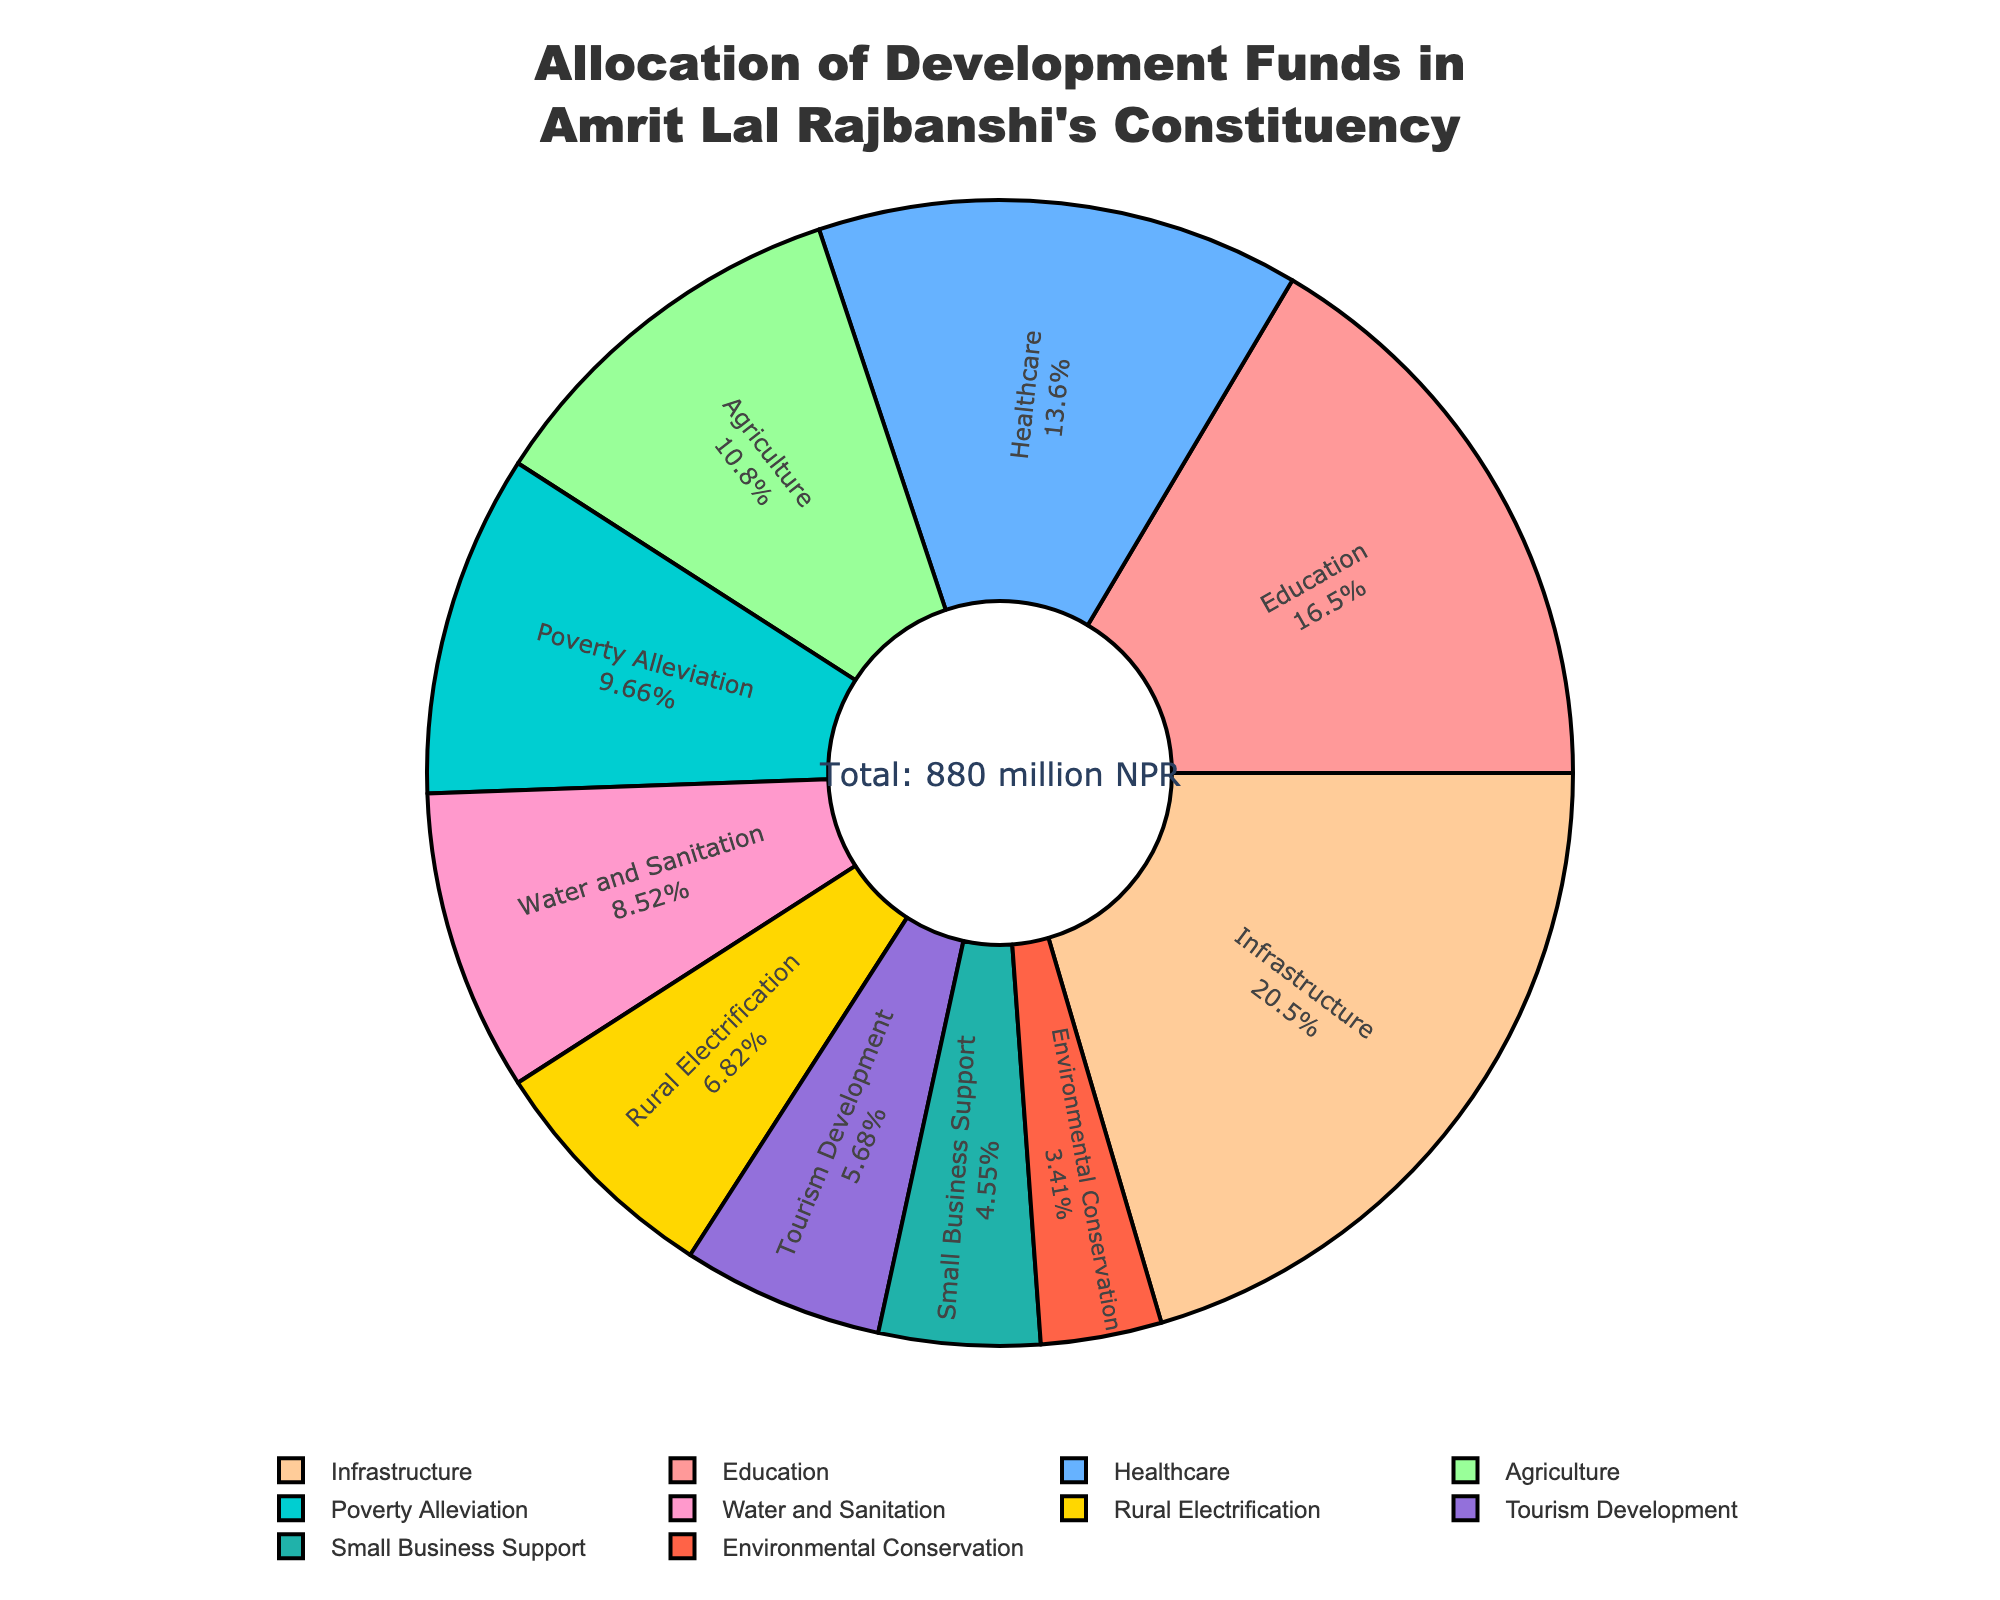What sector has the highest allocation of development funds? By looking at the size and the label of the largest section in the pie chart, we see that Infrastructure has the biggest allocation.
Answer: Infrastructure What percentage of the total development funds is allocated to Education? The pie chart provides labels with both sector names and their corresponding percentages. The percentage of funds allocated to Education can be read directly from the chart.
Answer: 20% How much more funds are allocated to Infrastructure compared to Environmental Conservation? Identify the allocations for both sectors from the pie chart: Infrastructure has 180 million NPR, and Environmental Conservation has 30 million NPR. Subtract the allocation of Environmental Conservation from Infrastructure: 180 - 30.
Answer: 150 million NPR Which sector has a smaller allocation of funds than Agriculture but a higher allocation than Environmental Conservation? Identify the allocations for Agriculture (95 million NPR) and Environmental Conservation (30 million NPR) from the pie chart, then look for a sector whose allocation is between these two values.
Answer: Poverty Alleviation What is the sum of allocations for sectors related to sustainability (Water and Sanitation, Rural Electrification, and Environmental Conservation)? Identify the allocations for these sectors: Water and Sanitation (75 million NPR), Rural Electrification (60 million NPR), and Environmental Conservation (30 million NPR). Sum these values: 75 + 60 + 30.
Answer: 165 million NPR How does the allocation for Healthcare compare to that for Small Business Support? The chart shows the allocation for Healthcare as 120 million NPR and for Small Business Support as 40 million NPR. Compare these two values by calculating the ratio: 120 / 40.
Answer: 3 times more Which two sectors, when their funds are combined, come closest to the total allocation for Infrastructure? The allocation for Infrastructure is 180 million NPR. Identify sector allocations that, when combined, are close to 180 million NPR. Education (145 million NPR) and Small Business Support (40 million NPR) combined make 145 + 40 = 185 million NPR.
Answer: Education and Small Business Support What is the difference in allocation between Agriculture and Tourism Development? The pie chart shows Agriculture with 95 million NPR and Tourism Development with 50 million NPR. Subtract the latter from the former: 95 - 50.
Answer: 45 million NPR Which sector has the second-highest allocation, and what percentage does it represent? Education has the second-highest allocation. Identify its percentage from the chart labels.
Answer: Education, 20% What proportion of the total funds is allocated to Poverty Alleviation compared to the total allocation for sectors directly related to infrastructure (Infrastructure and Rural Electrification)? Identify the allocations: Poverty Alleviation (85 million NPR), Infrastructure (180 million NPR), and Rural Electrification (60 million NPR). The total allocation for infrastructure-related sectors is 180 + 60 = 240 million NPR. Calculate the proportion: 85 / 240.
Answer: Approximately 0.354 or 35.4% 